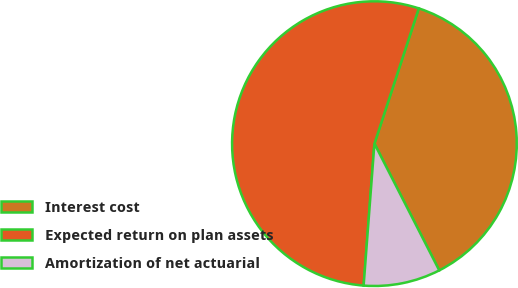<chart> <loc_0><loc_0><loc_500><loc_500><pie_chart><fcel>Interest cost<fcel>Expected return on plan assets<fcel>Amortization of net actuarial<nl><fcel>37.43%<fcel>53.83%<fcel>8.73%<nl></chart> 